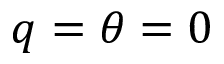<formula> <loc_0><loc_0><loc_500><loc_500>q = \theta = 0</formula> 